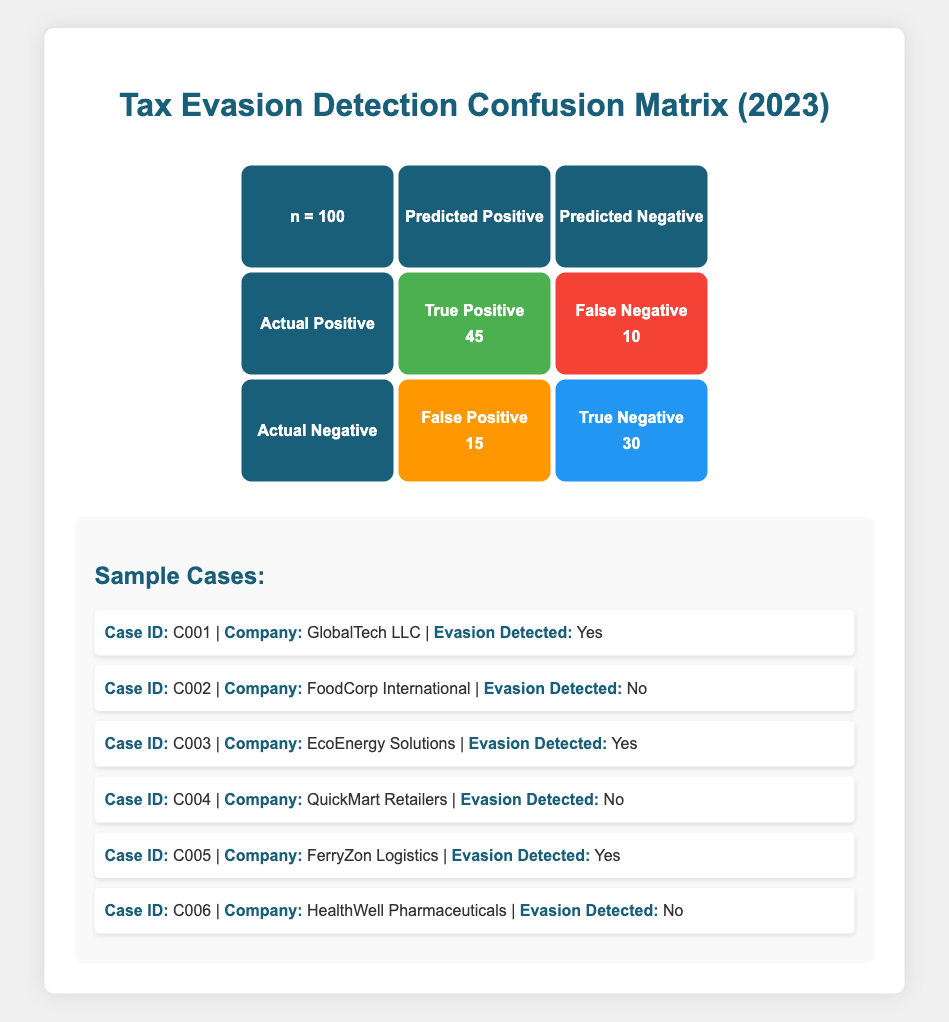What is the total number of cases analyzed in the confusion matrix? The table states that the total number of cases is represented as "n = 100" at the top of the matrix.
Answer: 100 How many true positive cases were identified? The matrix indicates that there are "True Positive" cases numbered as 45 in the relevant cell.
Answer: 45 What is the number of false negatives? The "False Negative" count is detailed in the table, listing 10 cases in that category.
Answer: 10 Is the number of true negatives greater than the number of false positives? The table shows "True Negative" as 30 and "False Positive" as 15. Since 30 is greater than 15, the statement is true.
Answer: Yes What is the total number of cases where tax evasion was detected (true positives) among the companies listed? According to the cases provided, GlobalTech LLC, EcoEnergy Solutions, and FerryZon Logistics indicate evasion, totaling 3 cases.
Answer: 3 What is the percentage of false positives in the analysis? To find the percentage, divide the number of false positives (15) by the total cases (100) and multiply by 100: (15/100) * 100 = 15%.
Answer: 15% Considering only the detected evasion cases, what percentage of them were true positives? The number of detected evasion cases is 45 (true positives) plus the sum of any detected cases, which is 45 in this instance: (45/45) * 100 = 100%. This means all detected evasion cases were verified as true positives.
Answer: 100% If we combine true positives and true negatives, what is their sum? The sum of true positives (45) and true negatives (30) is calculated as 45 + 30 = 75.
Answer: 75 What is the ratio of false negatives to true positives? To find the ratio, divide the number of false negatives (10) by true positives (45), resulting in a ratio of 10:45. This can be simplified to 2:9.
Answer: 2:9 